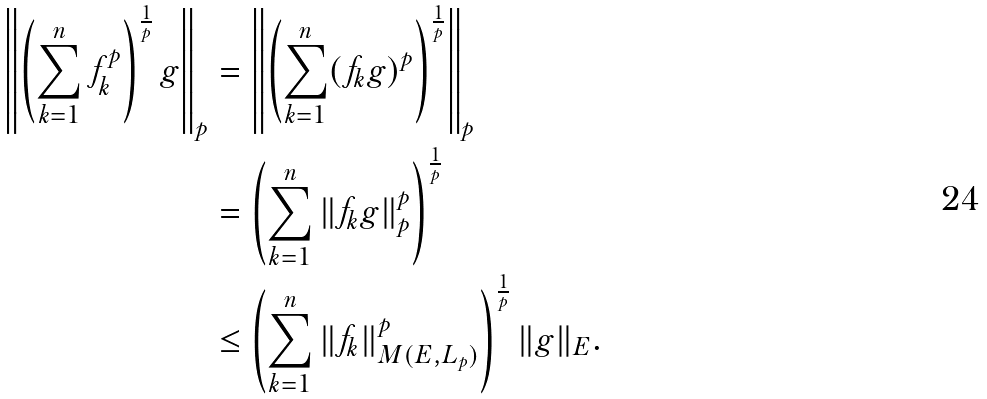Convert formula to latex. <formula><loc_0><loc_0><loc_500><loc_500>\left \| \left ( \sum _ { k = 1 } ^ { n } f _ { k } ^ { p } \right ) ^ { \frac { 1 } { p } } g \right \| _ { p } & = \left \| \left ( \sum _ { k = 1 } ^ { n } ( f _ { k } g ) ^ { p } \right ) ^ { \frac { 1 } { p } } \right \| _ { p } \\ & = \left ( \sum _ { k = 1 } ^ { n } \| f _ { k } g \| _ { p } ^ { p } \right ) ^ { \frac { 1 } { p } } \\ & \leq \left ( \sum _ { k = 1 } ^ { n } \| f _ { k } \| _ { M ( E , L _ { p } ) } ^ { p } \right ) ^ { \frac { 1 } { p } } \| g \| _ { E } .</formula> 